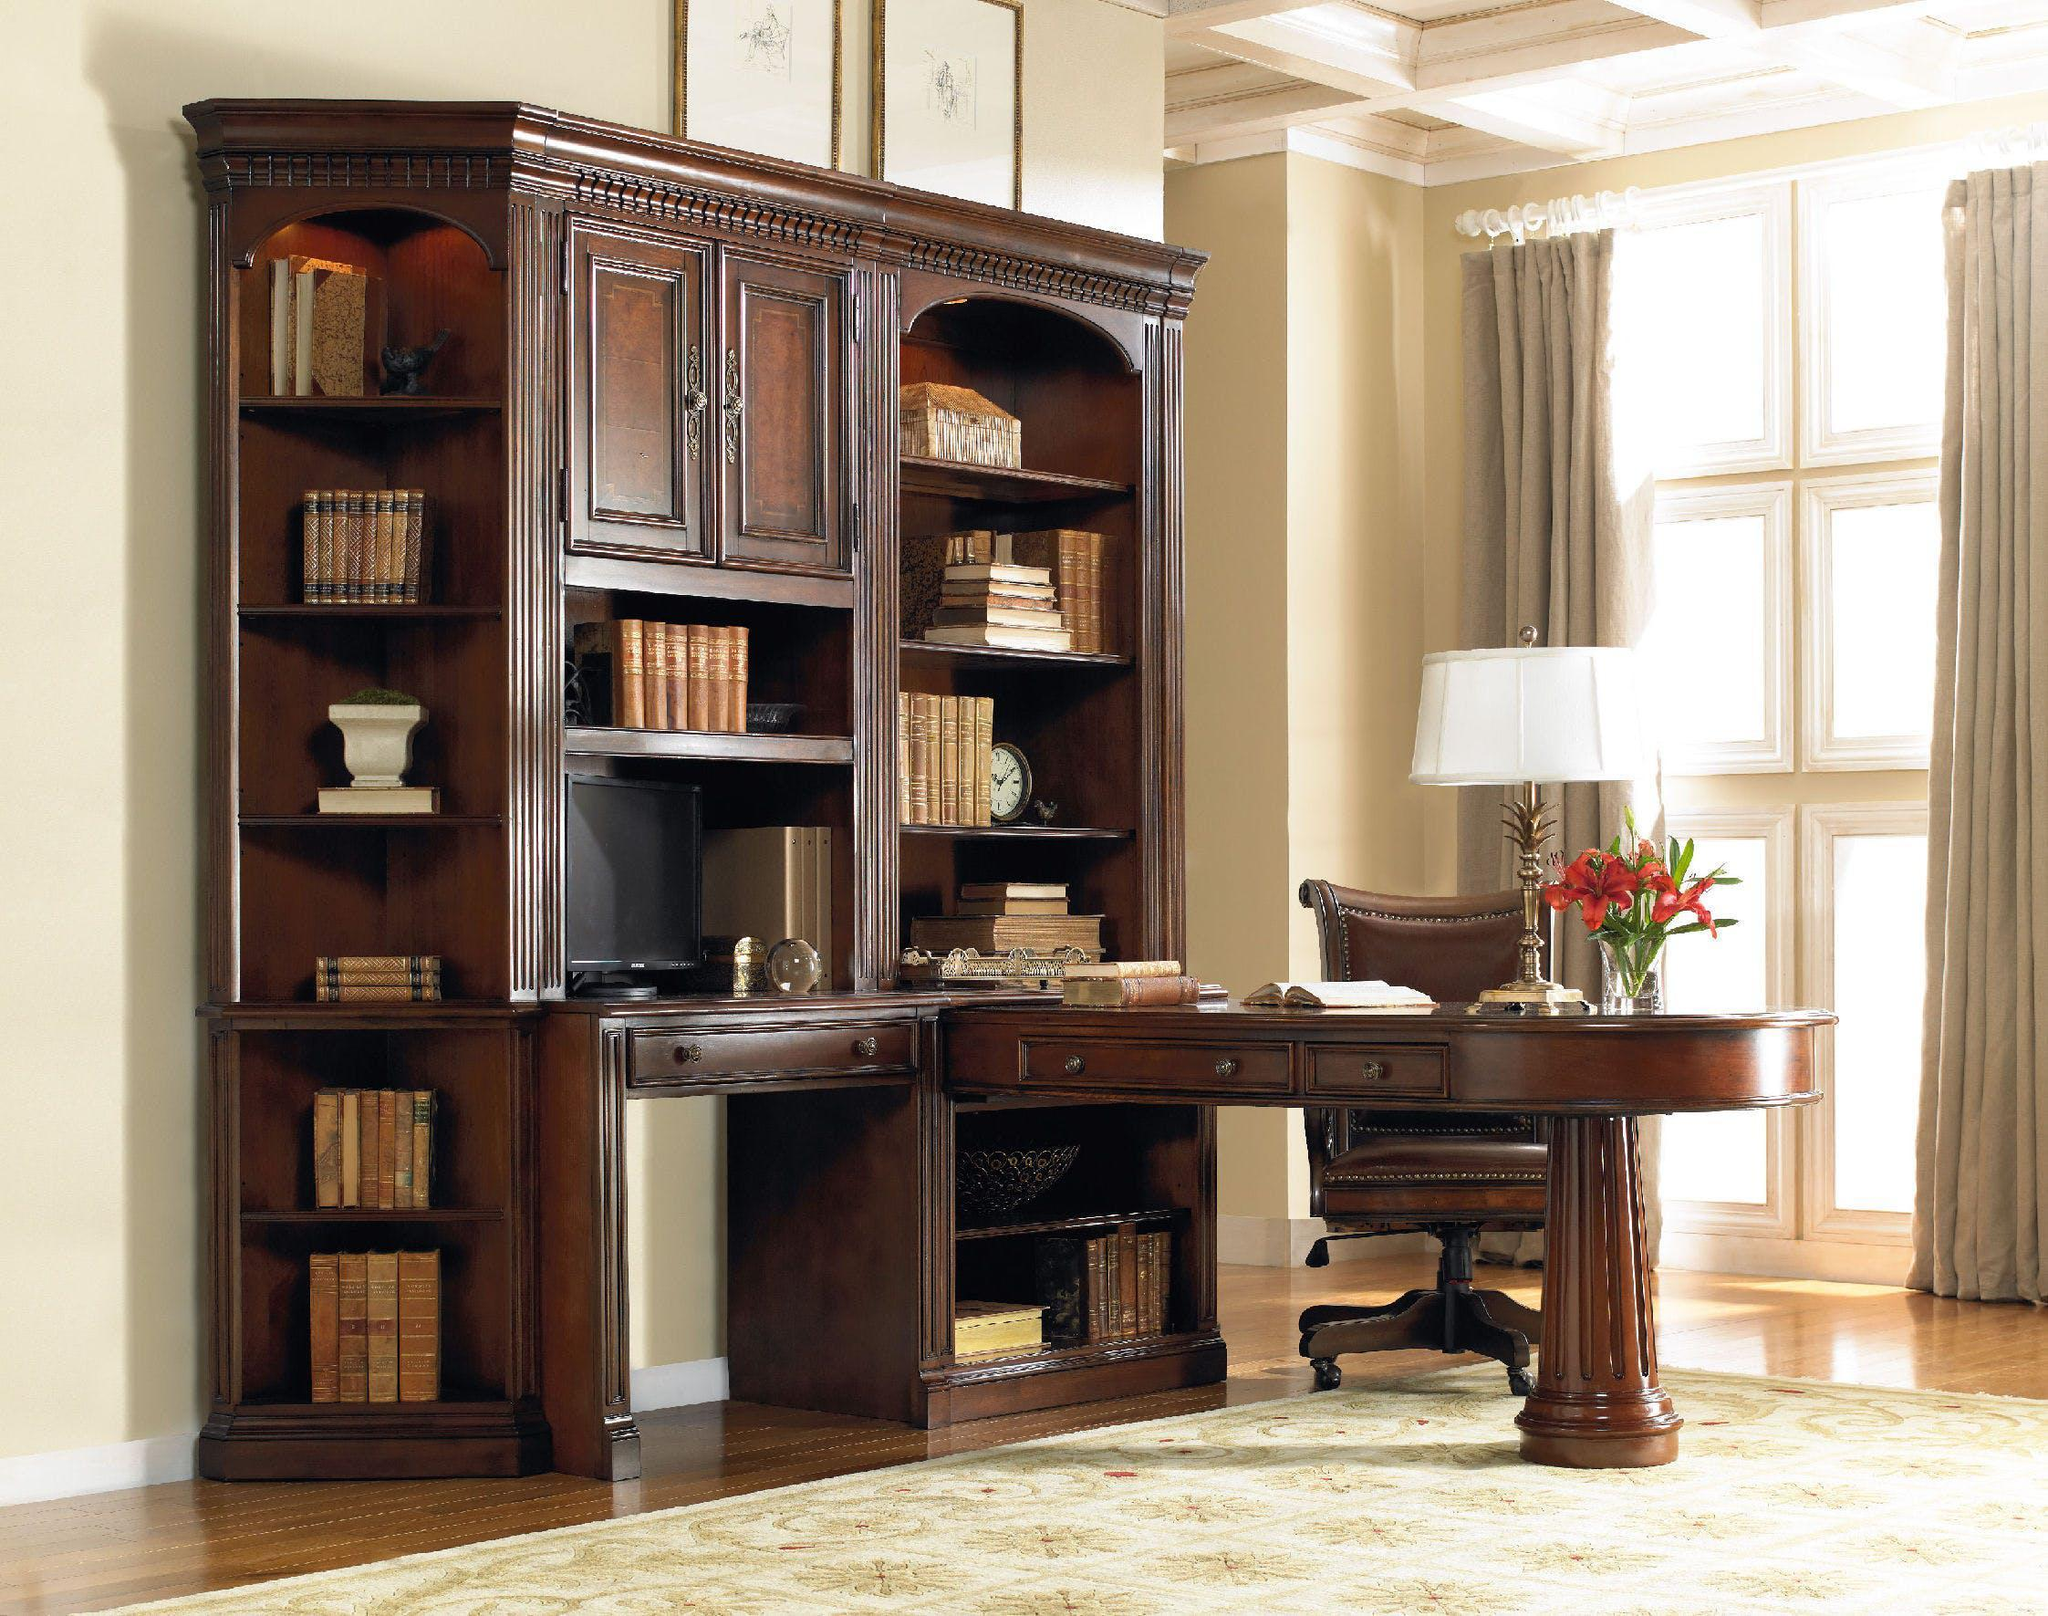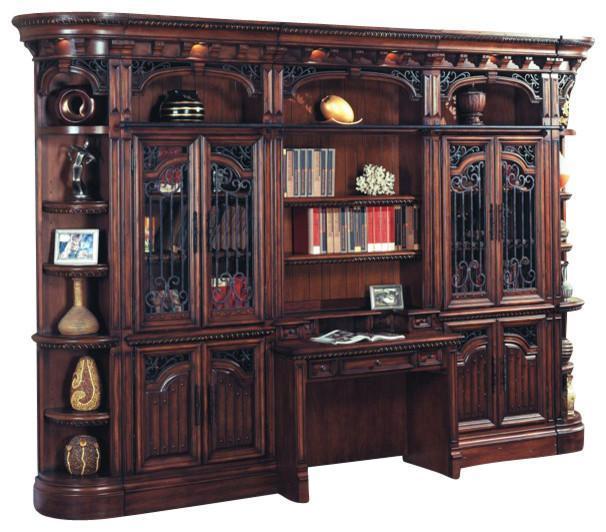The first image is the image on the left, the second image is the image on the right. Given the left and right images, does the statement "One image includes a simple gray desk with open shelves underneath and a matching slant-front set of shelves that resembles a ladder." hold true? Answer yes or no. No. The first image is the image on the left, the second image is the image on the right. Examine the images to the left and right. Is the description "In one image a leather chair is placed at a desk unit that is attached and perpendicular to a large bookcase." accurate? Answer yes or no. Yes. 